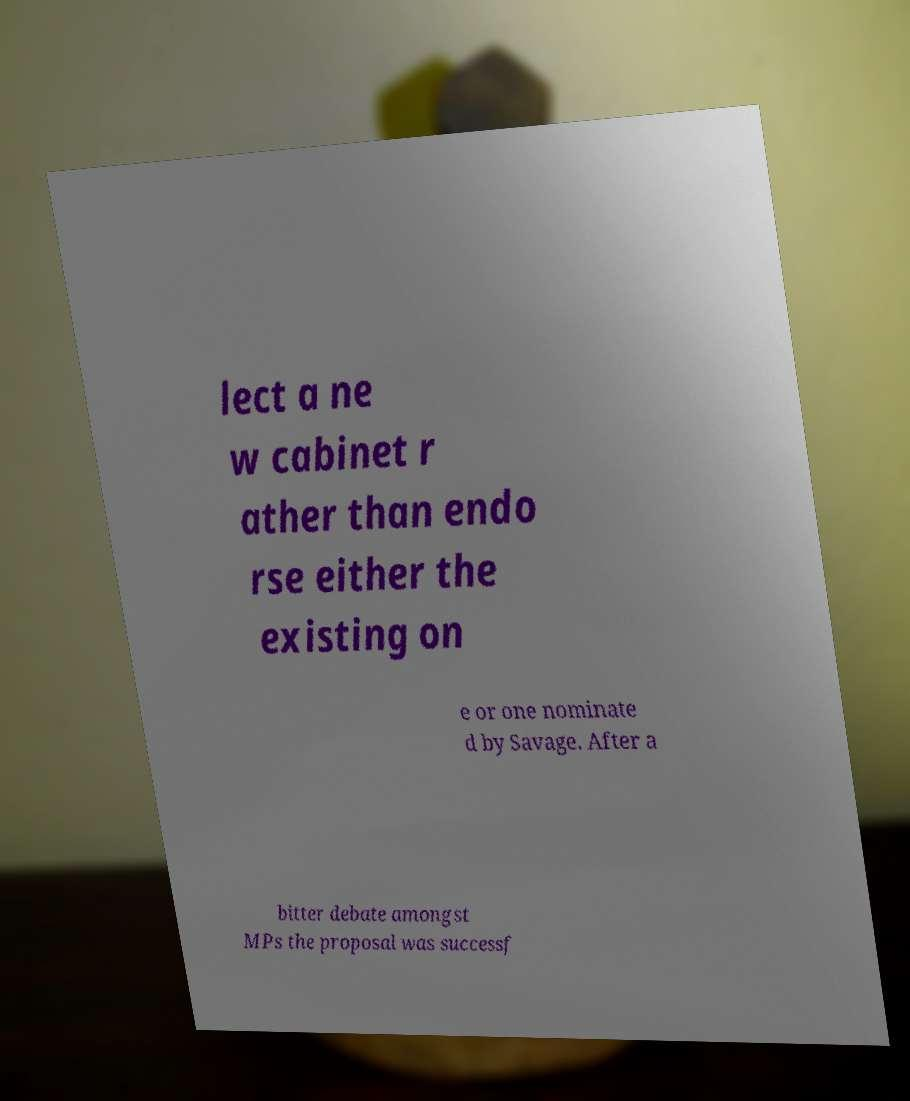Can you read and provide the text displayed in the image?This photo seems to have some interesting text. Can you extract and type it out for me? lect a ne w cabinet r ather than endo rse either the existing on e or one nominate d by Savage. After a bitter debate amongst MPs the proposal was successf 